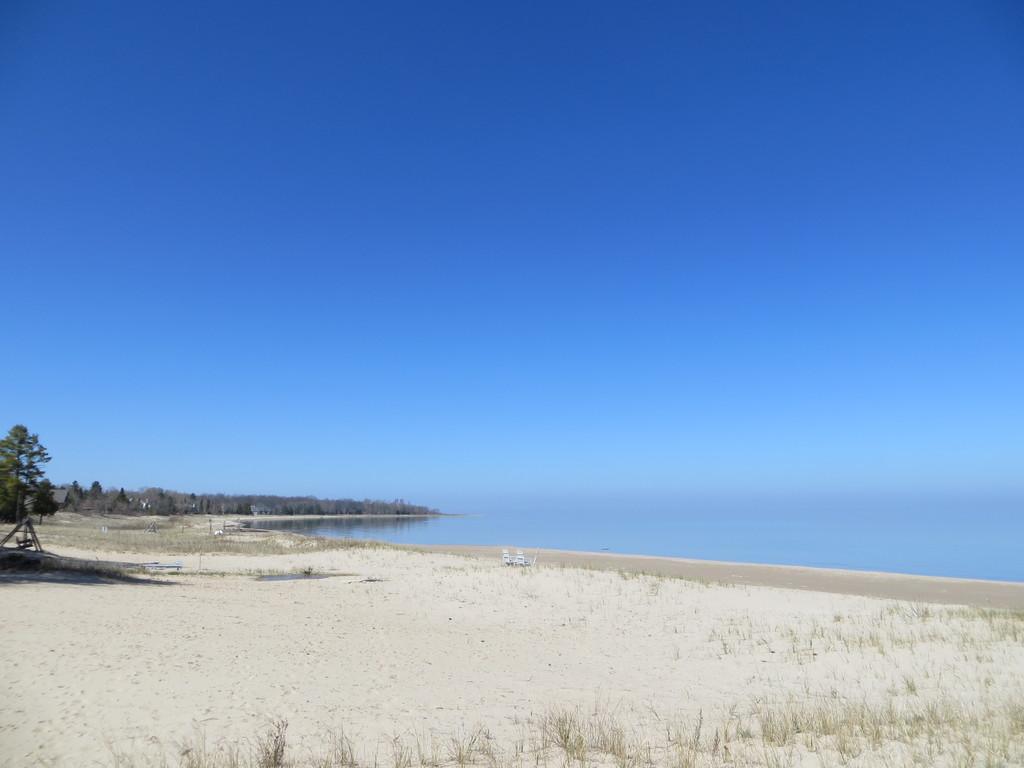Could you give a brief overview of what you see in this image? In this picture I can see the land on which there is grass and in the middle of this picture I can see a tree. On the right side of this picture I can see the water and in the background I can see the clear sky. 